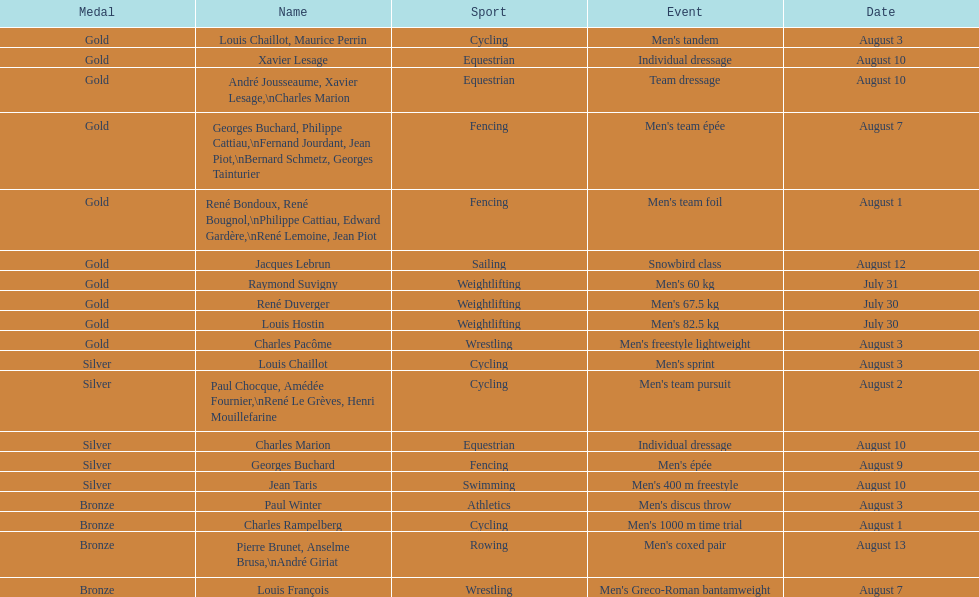Which occasion garnered the highest number of medals? Cycling. 